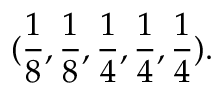Convert formula to latex. <formula><loc_0><loc_0><loc_500><loc_500>( \frac { 1 } { 8 } , \frac { 1 } { 8 } , \frac { 1 } { 4 } , \frac { 1 } { 4 } , \frac { 1 } { 4 } ) .</formula> 